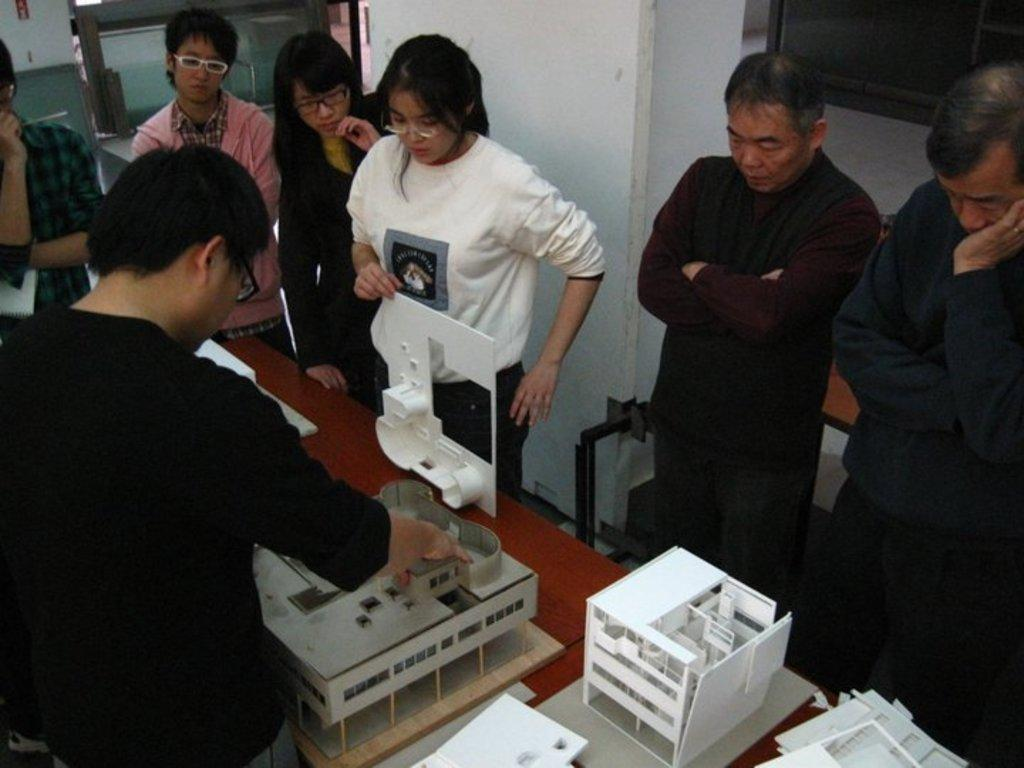Who is present in the image? There are women and men in the image. What are they doing in the image? They are standing on either side of a table. What is on the table in the image? There is a plan of a building on the table. What can be seen in the background of the image? There is a pillar visible in the background of the image. How many cats are sitting on the table in the image? There are no cats present in the image; it features women and men standing on either side of a table with a plan of a building. What type of ray is swimming in the background of the image? There is no ray present in the image; it features a pillar visible in the background. 